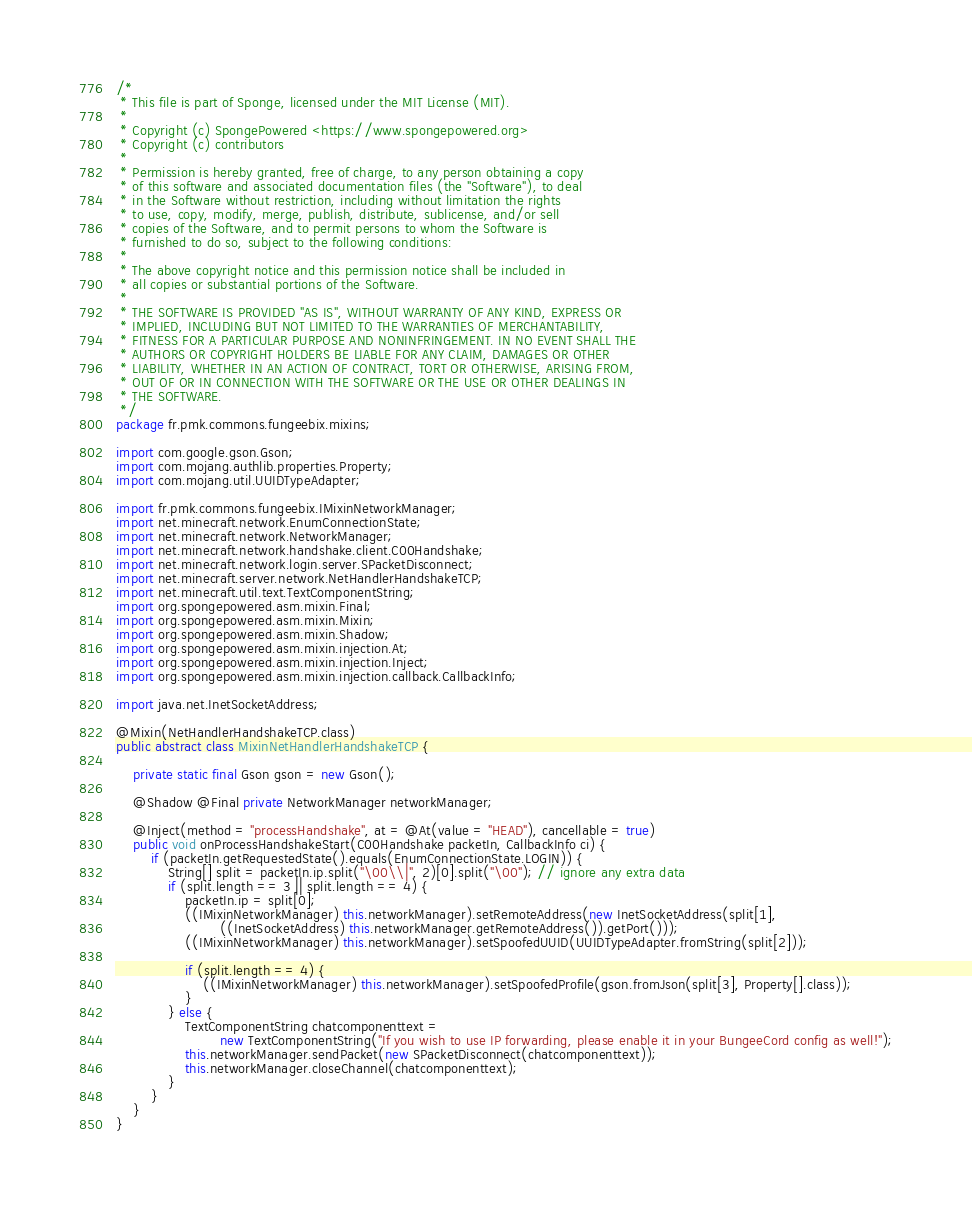Convert code to text. <code><loc_0><loc_0><loc_500><loc_500><_Java_>/*
 * This file is part of Sponge, licensed under the MIT License (MIT).
 *
 * Copyright (c) SpongePowered <https://www.spongepowered.org>
 * Copyright (c) contributors
 *
 * Permission is hereby granted, free of charge, to any person obtaining a copy
 * of this software and associated documentation files (the "Software"), to deal
 * in the Software without restriction, including without limitation the rights
 * to use, copy, modify, merge, publish, distribute, sublicense, and/or sell
 * copies of the Software, and to permit persons to whom the Software is
 * furnished to do so, subject to the following conditions:
 *
 * The above copyright notice and this permission notice shall be included in
 * all copies or substantial portions of the Software.
 *
 * THE SOFTWARE IS PROVIDED "AS IS", WITHOUT WARRANTY OF ANY KIND, EXPRESS OR
 * IMPLIED, INCLUDING BUT NOT LIMITED TO THE WARRANTIES OF MERCHANTABILITY,
 * FITNESS FOR A PARTICULAR PURPOSE AND NONINFRINGEMENT. IN NO EVENT SHALL THE
 * AUTHORS OR COPYRIGHT HOLDERS BE LIABLE FOR ANY CLAIM, DAMAGES OR OTHER
 * LIABILITY, WHETHER IN AN ACTION OF CONTRACT, TORT OR OTHERWISE, ARISING FROM,
 * OUT OF OR IN CONNECTION WITH THE SOFTWARE OR THE USE OR OTHER DEALINGS IN
 * THE SOFTWARE.
 */
package fr.pmk.commons.fungeebix.mixins;

import com.google.gson.Gson;
import com.mojang.authlib.properties.Property;
import com.mojang.util.UUIDTypeAdapter;

import fr.pmk.commons.fungeebix.IMixinNetworkManager;
import net.minecraft.network.EnumConnectionState;
import net.minecraft.network.NetworkManager;
import net.minecraft.network.handshake.client.C00Handshake;
import net.minecraft.network.login.server.SPacketDisconnect;
import net.minecraft.server.network.NetHandlerHandshakeTCP;
import net.minecraft.util.text.TextComponentString;
import org.spongepowered.asm.mixin.Final;
import org.spongepowered.asm.mixin.Mixin;
import org.spongepowered.asm.mixin.Shadow;
import org.spongepowered.asm.mixin.injection.At;
import org.spongepowered.asm.mixin.injection.Inject;
import org.spongepowered.asm.mixin.injection.callback.CallbackInfo;

import java.net.InetSocketAddress;

@Mixin(NetHandlerHandshakeTCP.class)
public abstract class MixinNetHandlerHandshakeTCP {

    private static final Gson gson = new Gson();

    @Shadow @Final private NetworkManager networkManager;

    @Inject(method = "processHandshake", at = @At(value = "HEAD"), cancellable = true)
    public void onProcessHandshakeStart(C00Handshake packetIn, CallbackInfo ci) {
        if (packetIn.getRequestedState().equals(EnumConnectionState.LOGIN)) {
            String[] split = packetIn.ip.split("\00\\|", 2)[0].split("\00"); // ignore any extra data
            if (split.length == 3 || split.length == 4) {
                packetIn.ip = split[0];
                ((IMixinNetworkManager) this.networkManager).setRemoteAddress(new InetSocketAddress(split[1],
                        ((InetSocketAddress) this.networkManager.getRemoteAddress()).getPort()));
                ((IMixinNetworkManager) this.networkManager).setSpoofedUUID(UUIDTypeAdapter.fromString(split[2]));

                if (split.length == 4) {
                    ((IMixinNetworkManager) this.networkManager).setSpoofedProfile(gson.fromJson(split[3], Property[].class));
                }
            } else {
                TextComponentString chatcomponenttext =
                        new TextComponentString("If you wish to use IP forwarding, please enable it in your BungeeCord config as well!");
                this.networkManager.sendPacket(new SPacketDisconnect(chatcomponenttext));
                this.networkManager.closeChannel(chatcomponenttext);
            }
        }
    }
}
</code> 